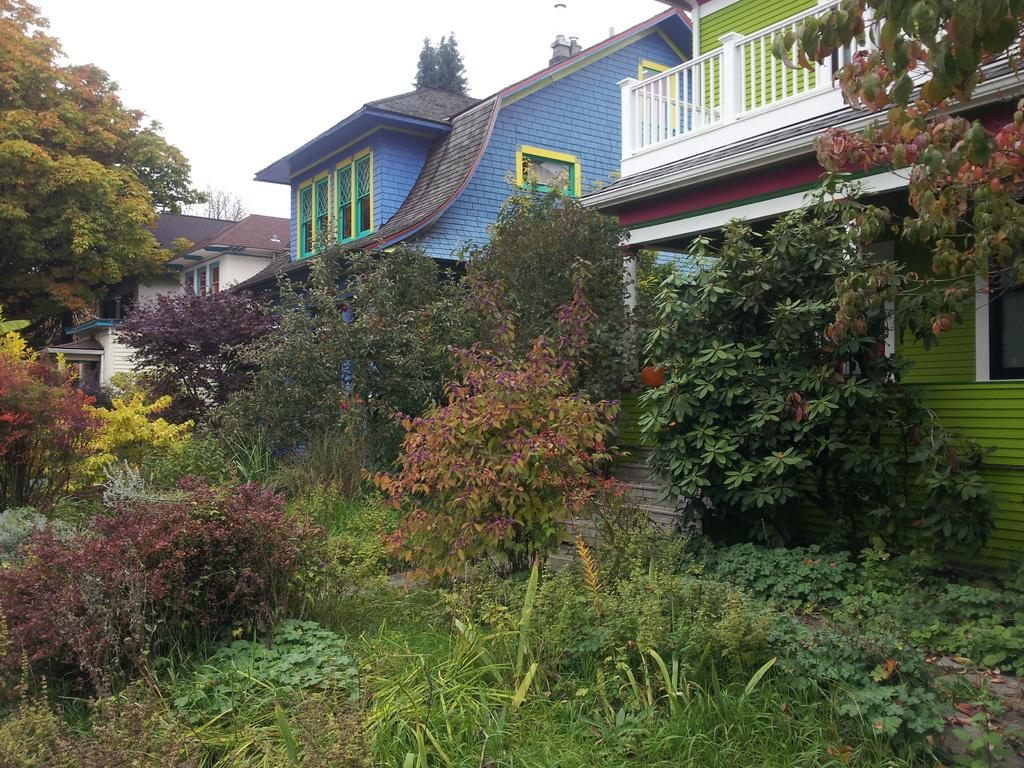What type of vegetation can be seen in the image? There are trees in the image. What type of structures are present in the image? There are houses in the image. What is visible in the background of the image? The sky is visible in the image. How many clocks can be seen hanging on the trees in the image? There are no clocks hanging on the trees in the image. What type of amphibian can be seen sitting on the roof of the house in the image? There are no amphibians, such as toads, present in the image. 